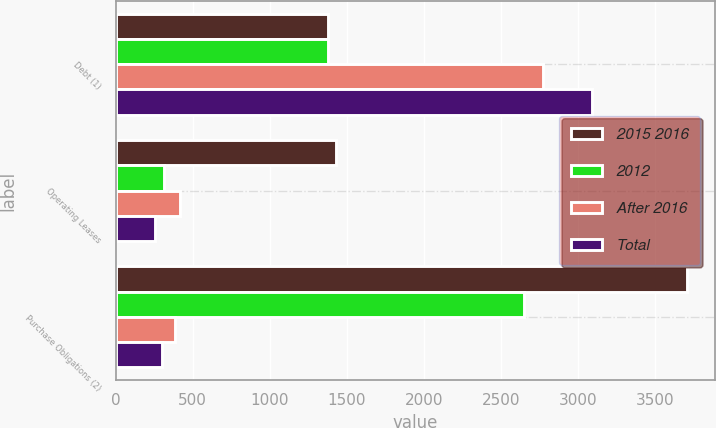Convert chart. <chart><loc_0><loc_0><loc_500><loc_500><stacked_bar_chart><ecel><fcel>Debt (1)<fcel>Operating Leases<fcel>Purchase Obligations (2)<nl><fcel>2015 2016<fcel>1377<fcel>1429<fcel>3707<nl><fcel>2012<fcel>1377<fcel>313<fcel>2647<nl><fcel>After 2016<fcel>2773<fcel>420<fcel>386<nl><fcel>Total<fcel>3089<fcel>255<fcel>298<nl></chart> 